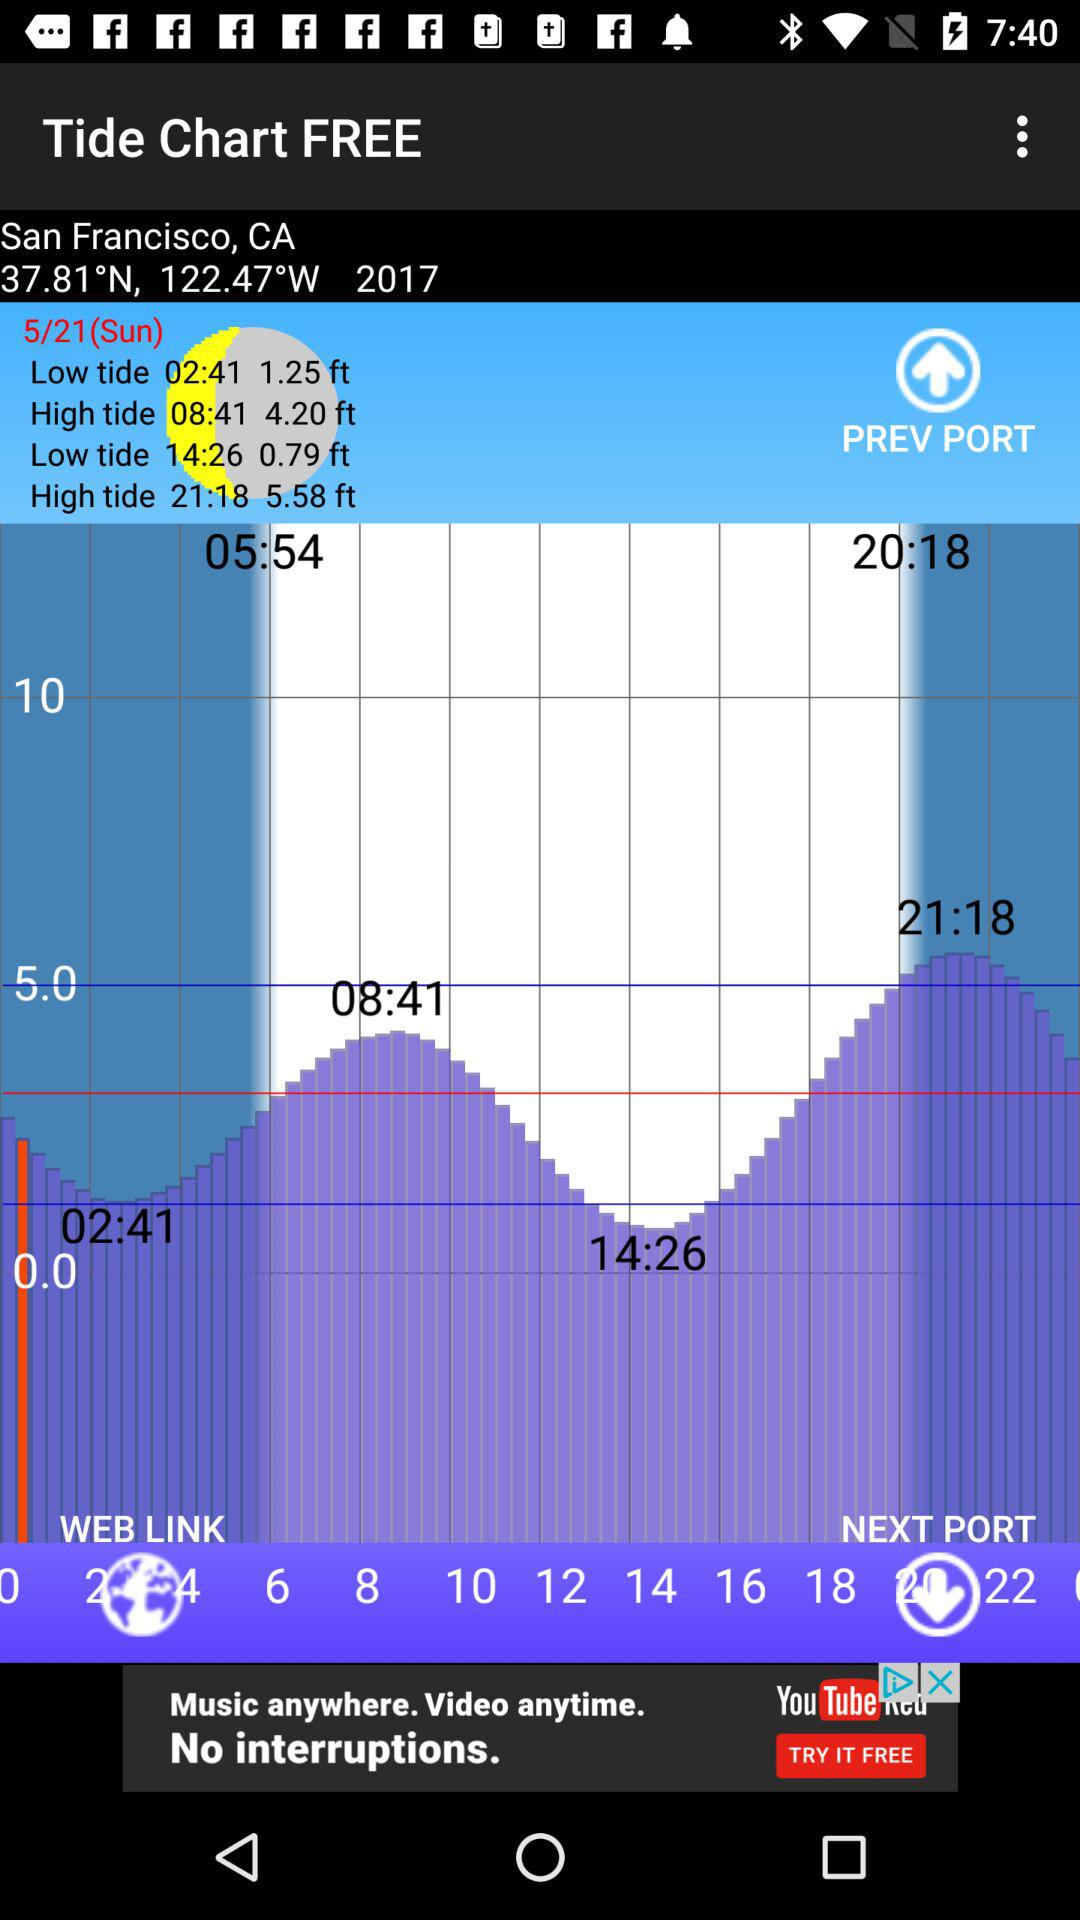Which tide was 1.25 feet high at 02:41? It was a low tide. 